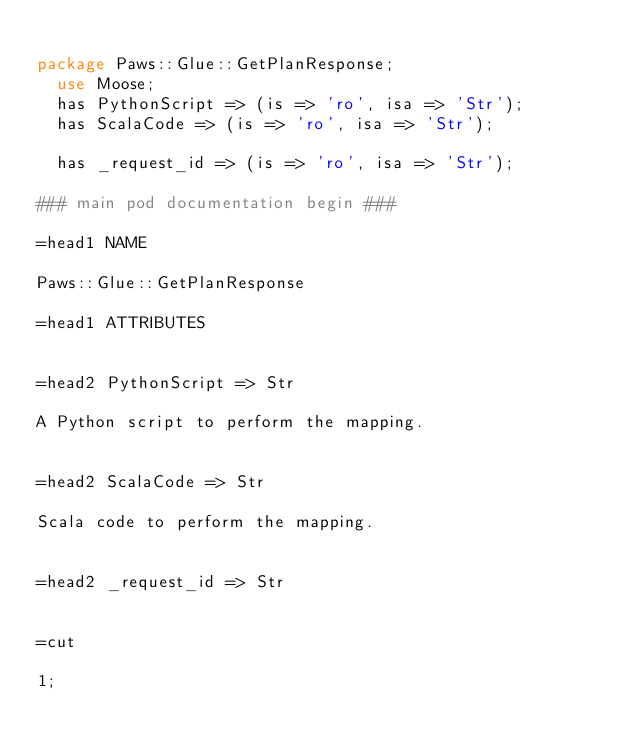<code> <loc_0><loc_0><loc_500><loc_500><_Perl_>
package Paws::Glue::GetPlanResponse;
  use Moose;
  has PythonScript => (is => 'ro', isa => 'Str');
  has ScalaCode => (is => 'ro', isa => 'Str');

  has _request_id => (is => 'ro', isa => 'Str');

### main pod documentation begin ###

=head1 NAME

Paws::Glue::GetPlanResponse

=head1 ATTRIBUTES


=head2 PythonScript => Str

A Python script to perform the mapping.


=head2 ScalaCode => Str

Scala code to perform the mapping.


=head2 _request_id => Str


=cut

1;</code> 